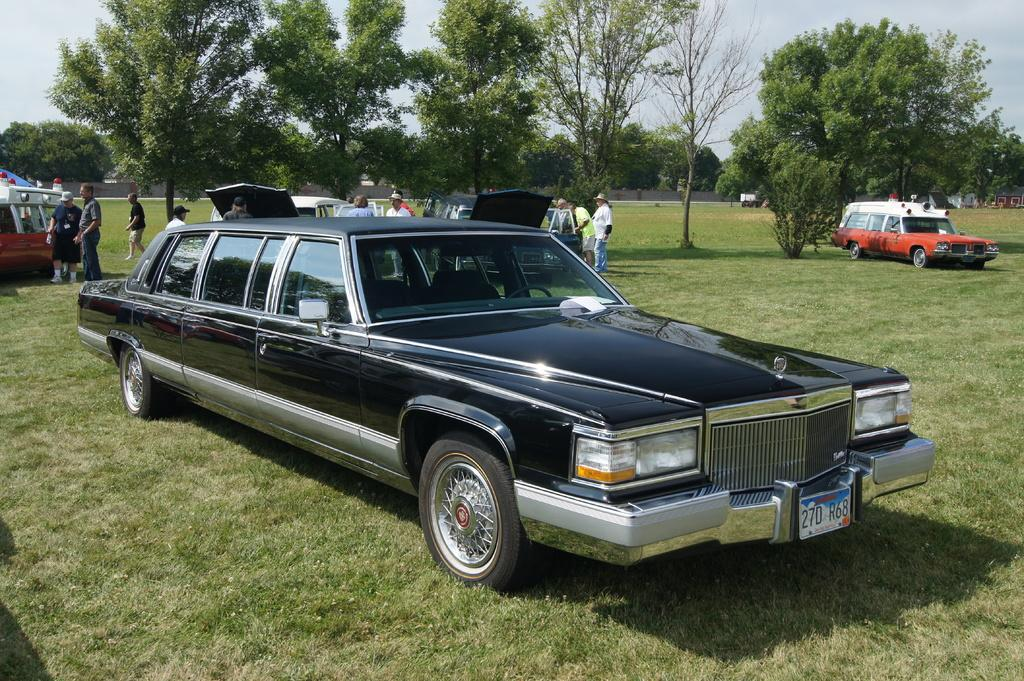What types of objects are present in the image? There are vehicles in the image. What else can be seen in the image besides the vehicles? There are persons standing on the ground in the image. How would you describe the surface where the persons are standing? The ground is described as greenery. What can be seen in the background of the image? There are trees in the background of the image. What historical event is being commemorated by the wristbands worn by the persons in the image? There is no mention of wristbands or any historical event in the image. 